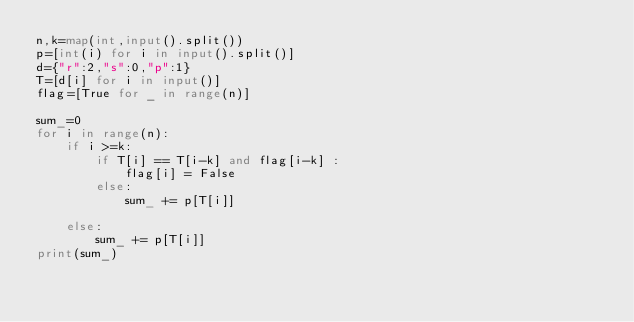<code> <loc_0><loc_0><loc_500><loc_500><_Python_>n,k=map(int,input().split())
p=[int(i) for i in input().split()]
d={"r":2,"s":0,"p":1}
T=[d[i] for i in input()]
flag=[True for _ in range(n)]

sum_=0
for i in range(n):
    if i >=k:
        if T[i] == T[i-k] and flag[i-k] :
            flag[i] = False
        else:
            sum_ += p[T[i]]
            
    else:
        sum_ += p[T[i]]
print(sum_)</code> 